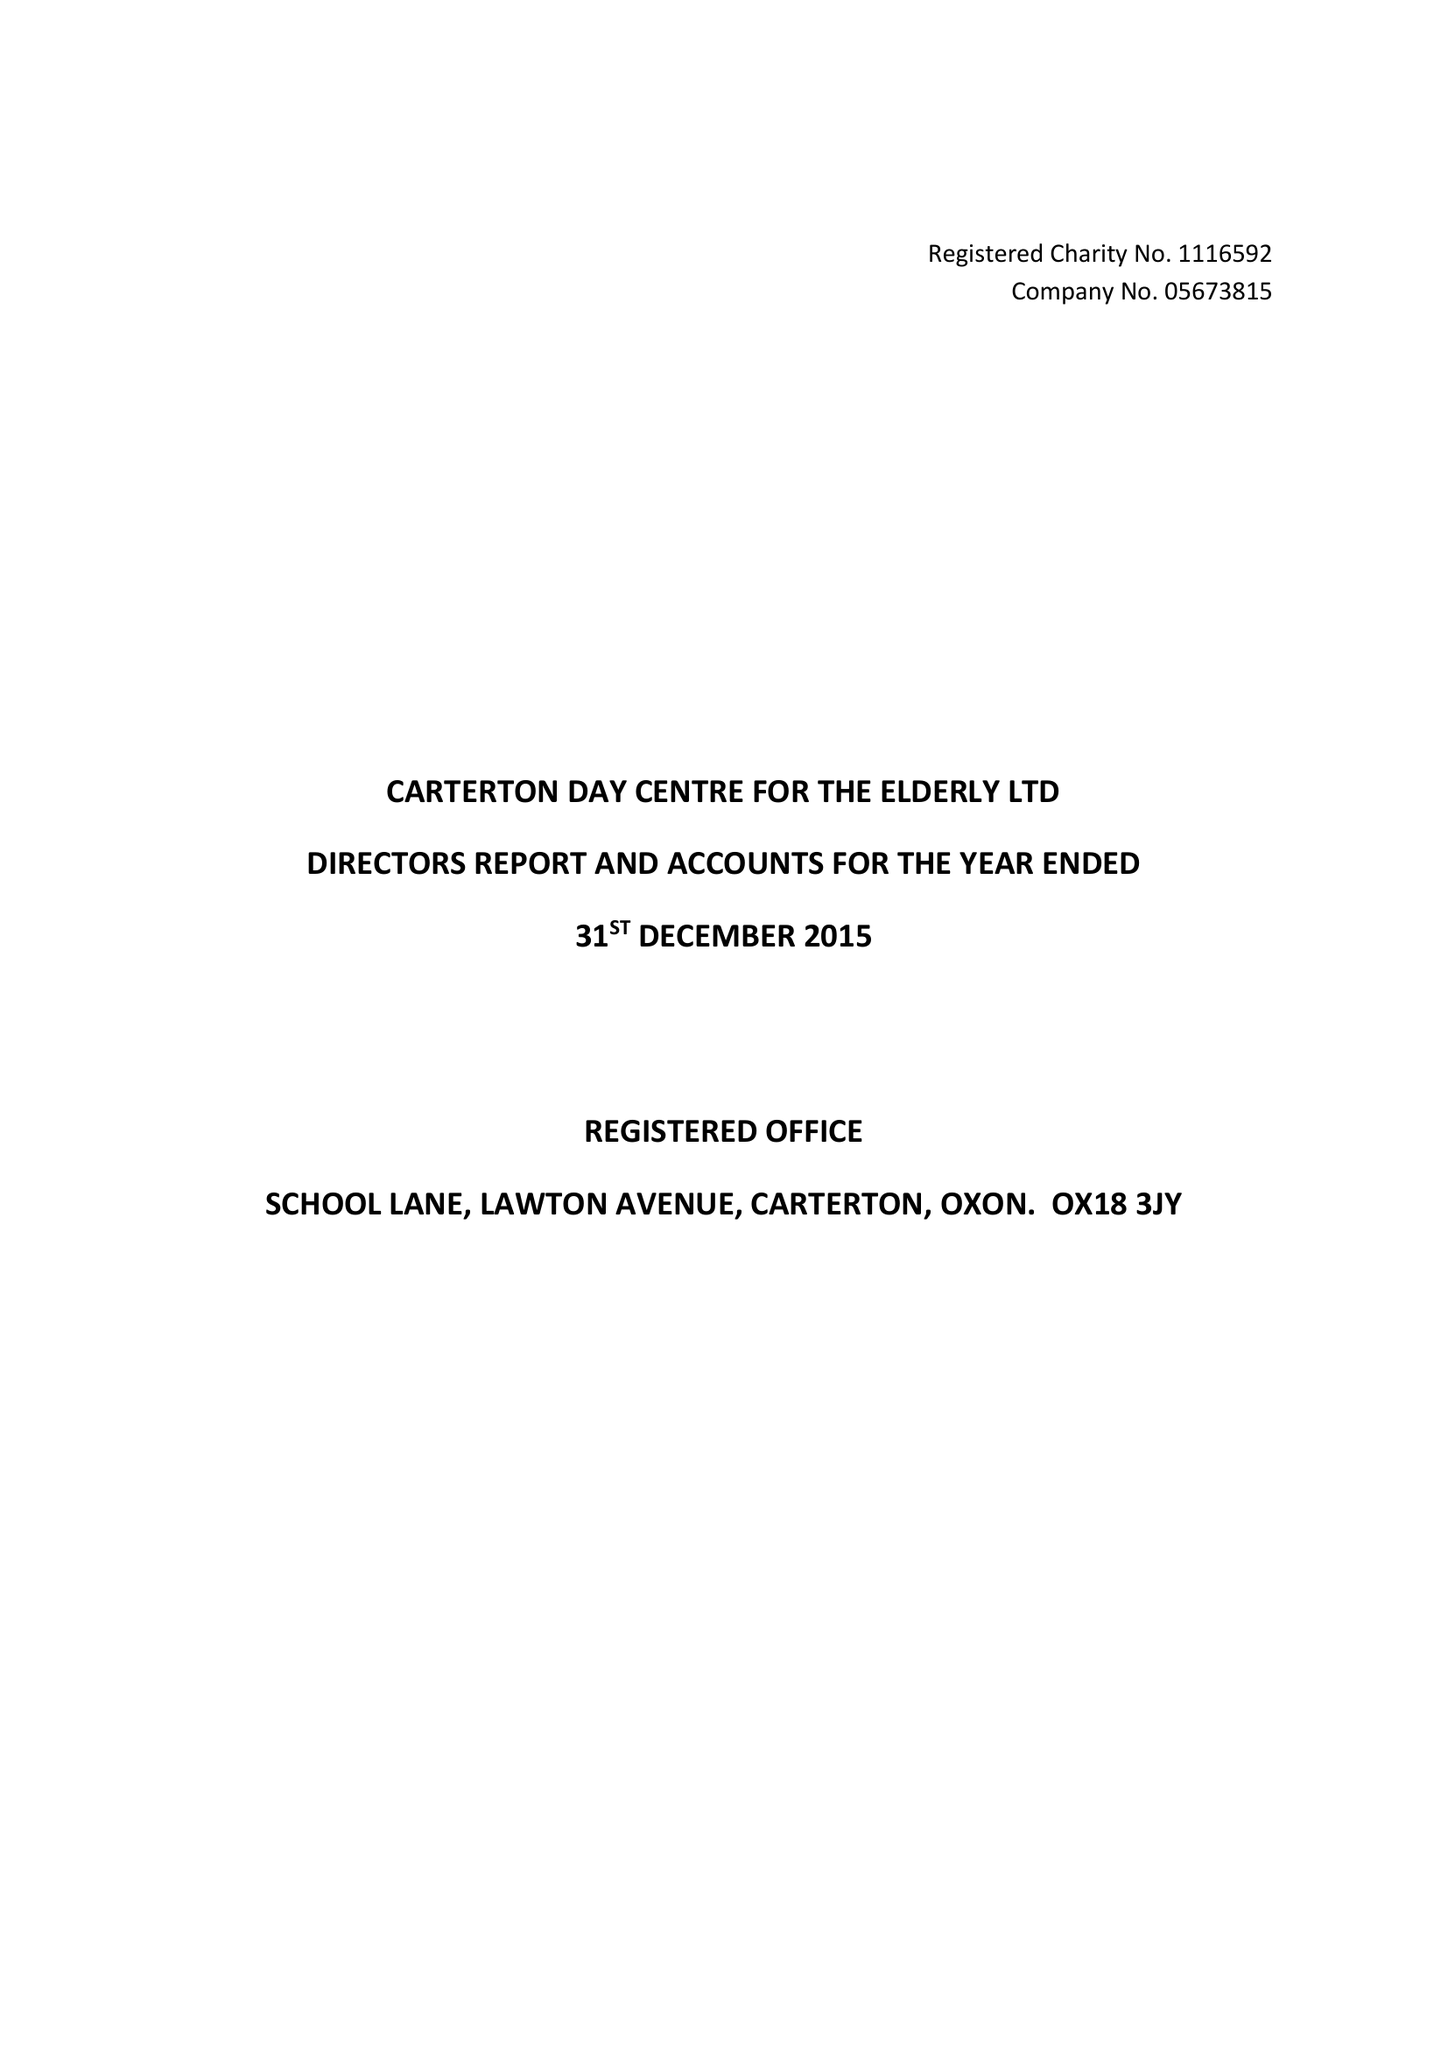What is the value for the income_annually_in_british_pounds?
Answer the question using a single word or phrase. 35321.00 